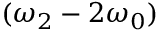Convert formula to latex. <formula><loc_0><loc_0><loc_500><loc_500>( \omega _ { 2 } - 2 \omega _ { 0 } )</formula> 